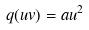<formula> <loc_0><loc_0><loc_500><loc_500>q ( u v ) = a u ^ { 2 }</formula> 